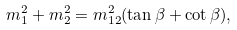<formula> <loc_0><loc_0><loc_500><loc_500>m _ { 1 } ^ { 2 } + m _ { 2 } ^ { 2 } = m _ { 1 2 } ^ { 2 } ( \tan \beta + \cot \beta ) ,</formula> 